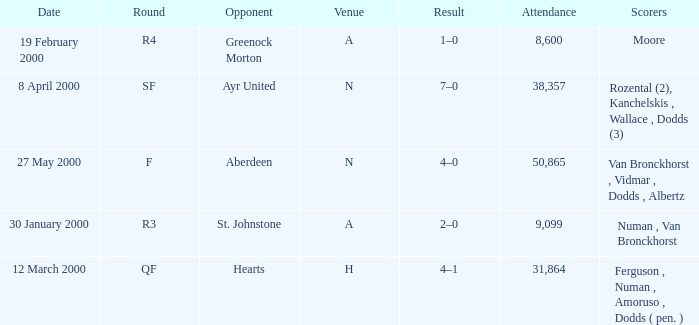Who was in a with opponent St. Johnstone? Numan , Van Bronckhorst. 